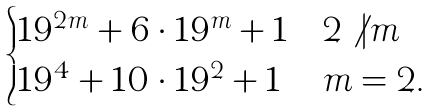<formula> <loc_0><loc_0><loc_500><loc_500>\begin{cases} 1 9 ^ { 2 m } + 6 \cdot 1 9 ^ { m } + 1 & 2 \not | m \\ 1 9 ^ { 4 } + 1 0 \cdot 1 9 ^ { 2 } + 1 & m = 2 . \end{cases}</formula> 